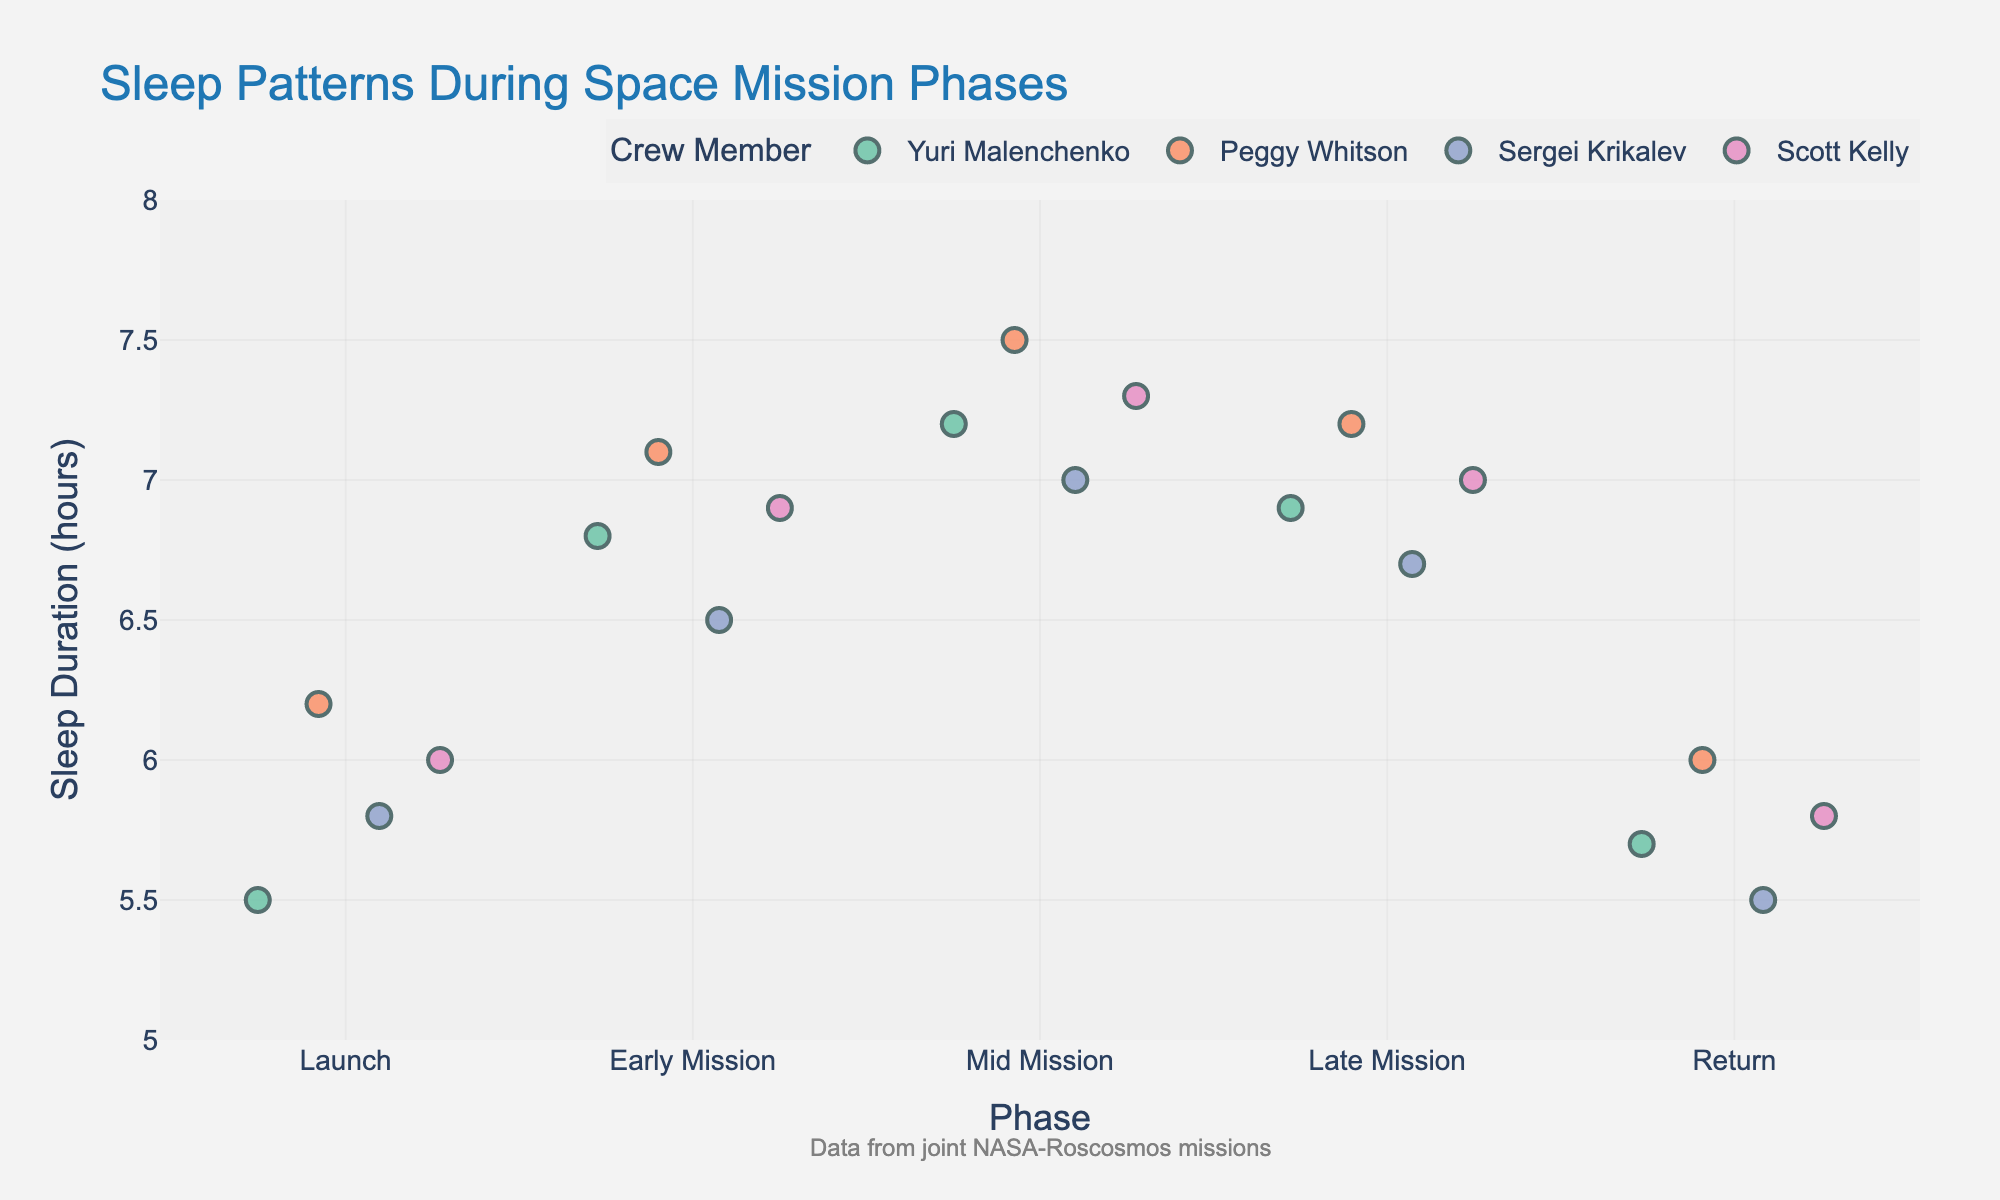How many distinct crew members' sleep patterns are represented in the plot? By looking at the legend in the figure, we can count the number of distinct crew members listed.
Answer: 4 What is the range of sleep durations recorded for the "Mid Mission" phase? By observing the "Mid Mission" phase on the x-axis and looking at the highest and lowest points, we can see that the sleep durations range from 7.0 to 7.5 hours.
Answer: 7.0 to 7.5 hours Which crew member has the most consistent sleep duration across all phases? By comparing the sleep durations for each crew member across all phases, Peggy Whitson's data points are closest together and show little variation.
Answer: Peggy Whitson During which mission phase do crew members generally get the least amount of sleep? By comparing the position of points across all phases, we can see that the "Return" phase has the lowest sleep durations.
Answer: Return What's the difference in sleep duration for Yuri Malenchenko from "Launch" to "Mid Mission"? Yuri Malenchenko's sleep duration during "Launch" is 5.5 hours, and during "Mid Mission" is 7.2 hours. By subtracting these, the difference is 7.2 - 5.5.
Answer: 1.7 hours What is the overall trend in sleep duration as the mission progresses from "Launch" to "Return" for Scott Kelly? Observing Scott Kelly's data points across the phases, the sleep duration generally increases from "Launch" to "Mid Mission" and then decreases again towards "Return".
Answer: Increases then decreases Which phase shows the most variation in sleep durations for all crew members? By visually comparing the spread of data points for each phase, the "Early Mission" phase has the widest spread in sleep durations.
Answer: Early Mission How does Sergei Krikalev's sleep duration change from "Mid Mission" to "Return"? Sergei Krikalev's sleep duration during "Mid Mission" is 7.0 hours, and during "Return" is 5.5 hours; the change is a decrease of 1.5 hours.
Answer: Decreases by 1.5 hours What is the average sleep duration for crew members during the "Late Mission" phase? By summing the sleep durations for "Late Mission" and dividing by the number of crew members: (6.9 + 7.2 + 6.7 + 7.0) / 4 = 27.8 / 4.
Answer: 6.95 hours 